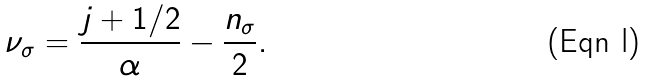<formula> <loc_0><loc_0><loc_500><loc_500>\nu _ { \sigma } = \frac { j + 1 / 2 } { \alpha } - \frac { n _ { \sigma } } { 2 } .</formula> 